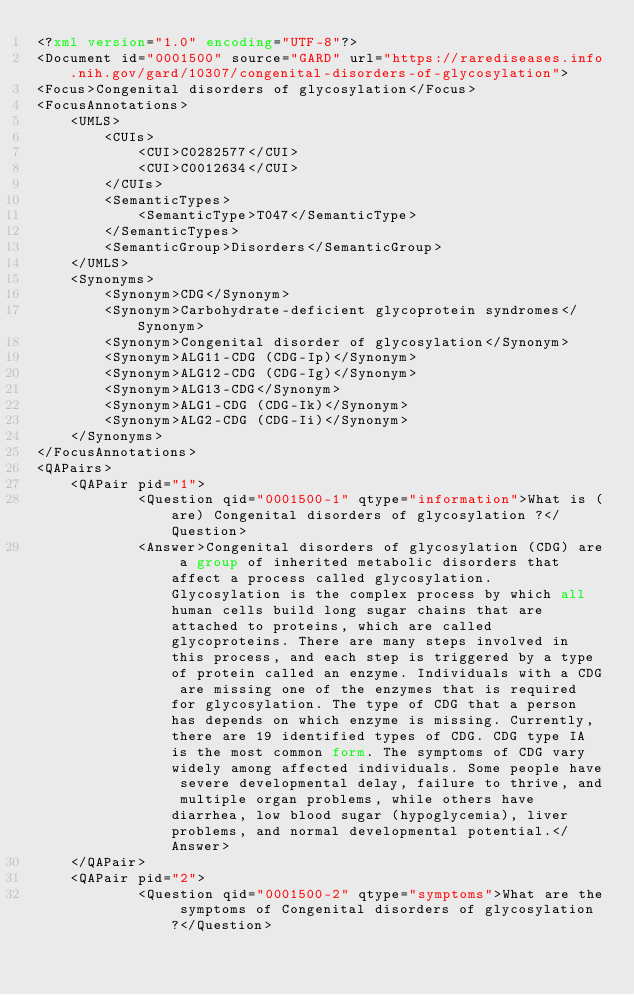<code> <loc_0><loc_0><loc_500><loc_500><_XML_><?xml version="1.0" encoding="UTF-8"?>
<Document id="0001500" source="GARD" url="https://rarediseases.info.nih.gov/gard/10307/congenital-disorders-of-glycosylation">
<Focus>Congenital disorders of glycosylation</Focus>
<FocusAnnotations>
	<UMLS>
		<CUIs>
			<CUI>C0282577</CUI>
			<CUI>C0012634</CUI>
		</CUIs>
		<SemanticTypes>
			<SemanticType>T047</SemanticType>
		</SemanticTypes>
		<SemanticGroup>Disorders</SemanticGroup>
	</UMLS>
	<Synonyms>
		<Synonym>CDG</Synonym>
		<Synonym>Carbohydrate-deficient glycoprotein syndromes</Synonym>
		<Synonym>Congenital disorder of glycosylation</Synonym>
		<Synonym>ALG11-CDG (CDG-Ip)</Synonym>
		<Synonym>ALG12-CDG (CDG-Ig)</Synonym>
		<Synonym>ALG13-CDG</Synonym>
		<Synonym>ALG1-CDG (CDG-Ik)</Synonym>
		<Synonym>ALG2-CDG (CDG-Ii)</Synonym>
	</Synonyms>
</FocusAnnotations>
<QAPairs>
	<QAPair pid="1">
			<Question qid="0001500-1" qtype="information">What is (are) Congenital disorders of glycosylation ?</Question>
			<Answer>Congenital disorders of glycosylation (CDG) are a group of inherited metabolic disorders that affect a process called glycosylation. Glycosylation is the complex process by which all human cells build long sugar chains that are attached to proteins, which are called glycoproteins. There are many steps involved in this process, and each step is triggered by a type of protein called an enzyme. Individuals with a CDG are missing one of the enzymes that is required for glycosylation. The type of CDG that a person has depends on which enzyme is missing. Currently, there are 19 identified types of CDG. CDG type IA is the most common form. The symptoms of CDG vary widely among affected individuals. Some people have severe developmental delay, failure to thrive, and multiple organ problems, while others have diarrhea, low blood sugar (hypoglycemia), liver problems, and normal developmental potential.</Answer>
	</QAPair>
	<QAPair pid="2">
			<Question qid="0001500-2" qtype="symptoms">What are the symptoms of Congenital disorders of glycosylation ?</Question></code> 